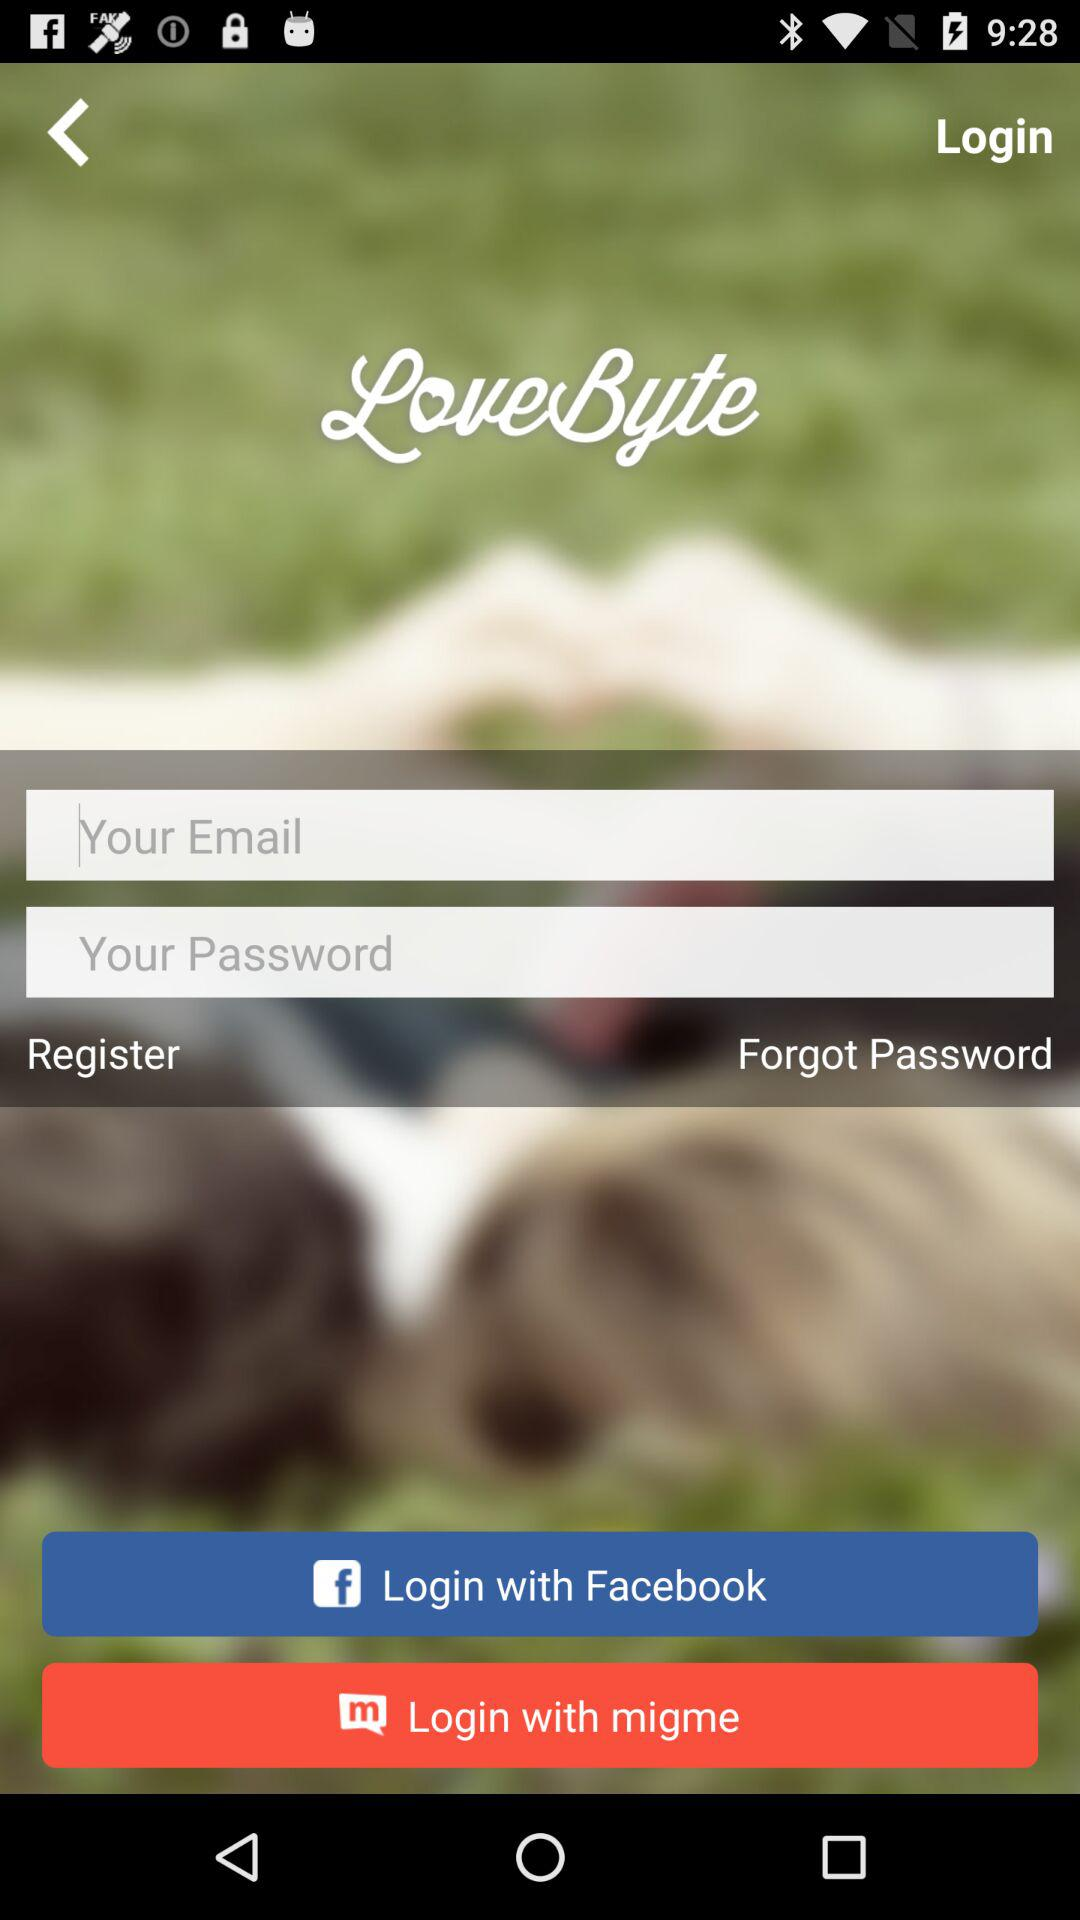What are the options through which we can log in? You can log in through "Facebook" and "migme". 